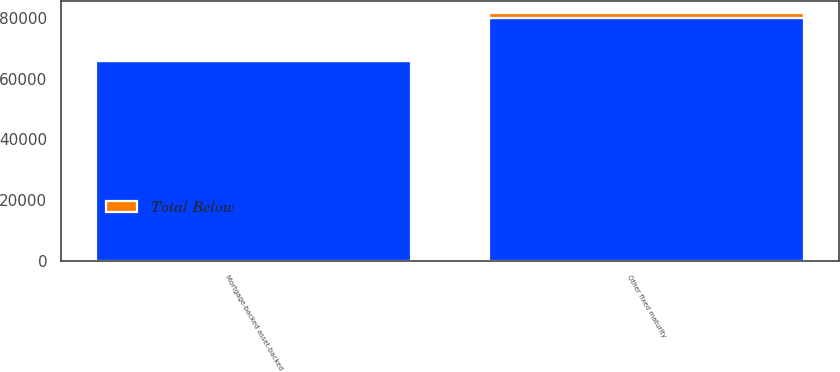Convert chart to OTSL. <chart><loc_0><loc_0><loc_500><loc_500><stacked_bar_chart><ecel><fcel>Other fixed maturity<fcel>Mortgage-backed asset-backed<nl><fcel>nan<fcel>80257<fcel>65767<nl><fcel>Total Below<fcel>1432<fcel>84<nl></chart> 